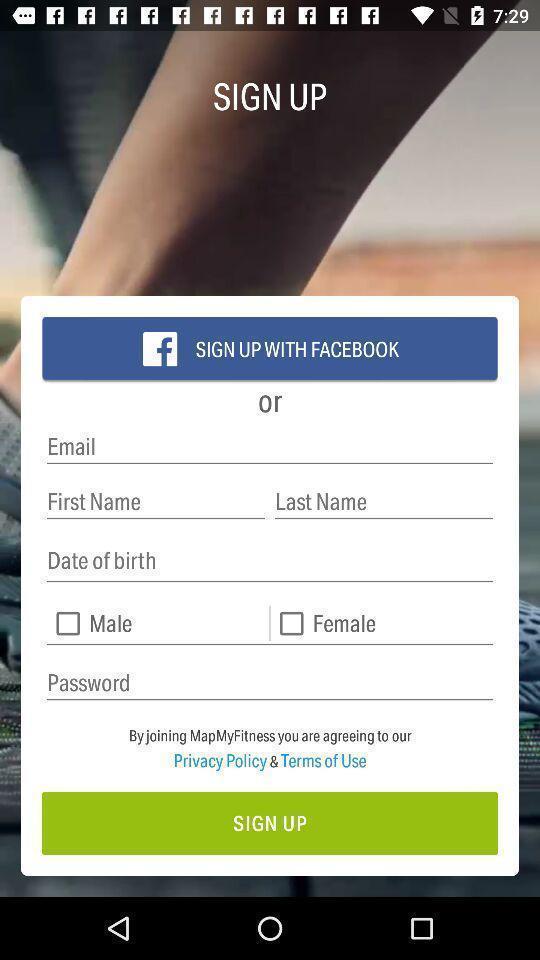What details can you identify in this image? Sign-up page for a fitness app. 